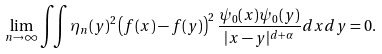<formula> <loc_0><loc_0><loc_500><loc_500>\lim _ { n \rightarrow \infty } \iint \eta _ { n } ( y ) ^ { 2 } \left ( f ( x ) - f ( y ) \right ) ^ { 2 } \frac { \psi _ { 0 } ( x ) \psi _ { 0 } ( y ) } { | x - y | ^ { d + \alpha } } d x d y = 0 .</formula> 